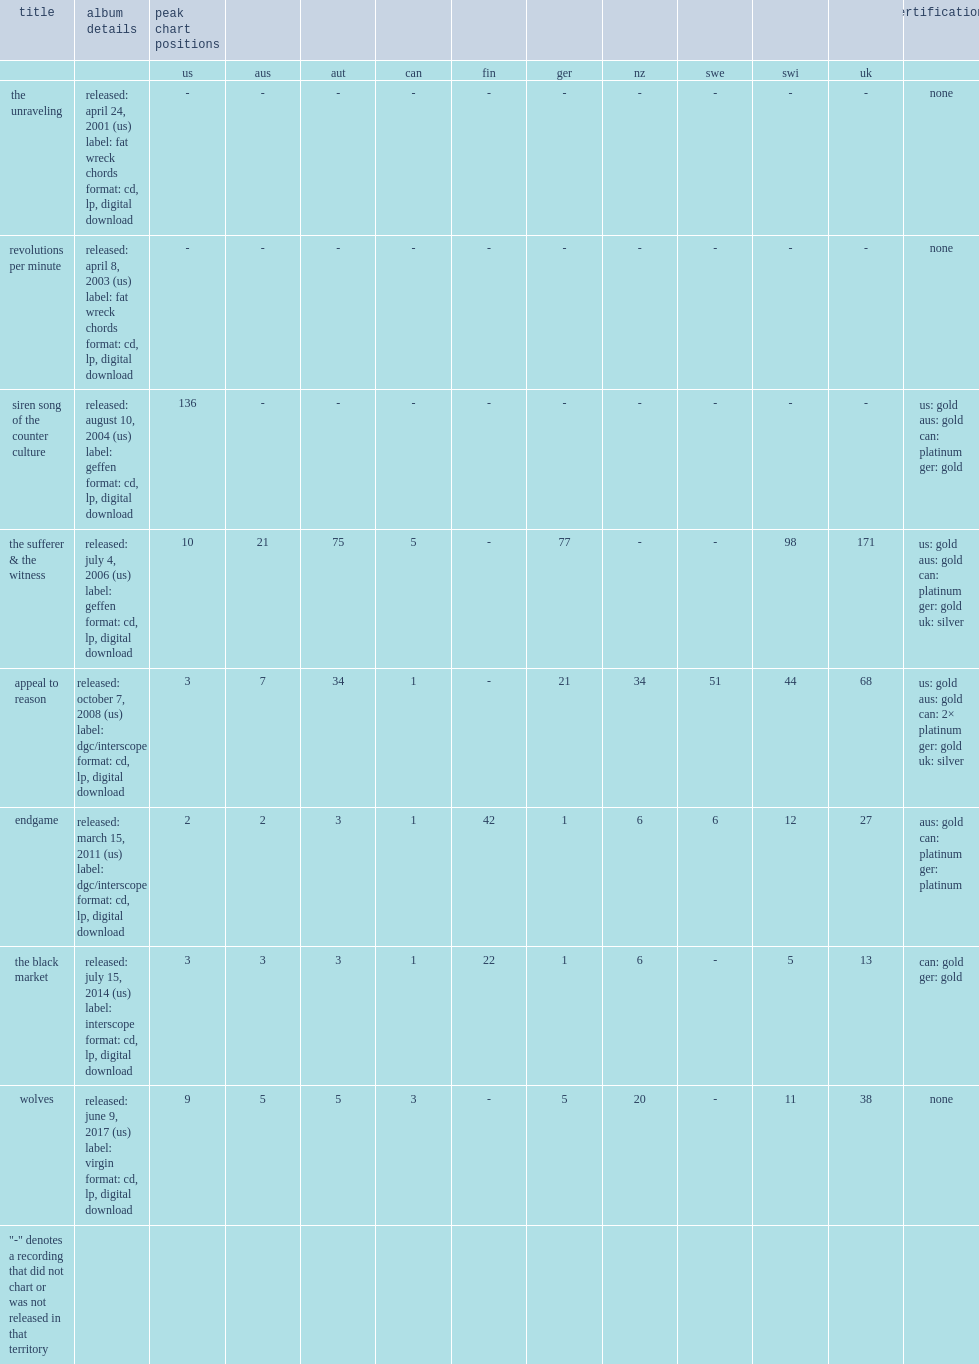What was the peak chart position on the billboard 200 of siren song of the counter culture? 136.0. 